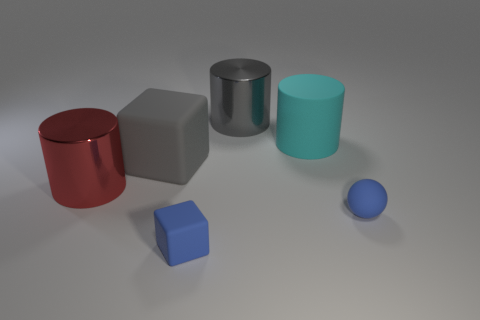There is a gray cylinder; is its size the same as the cylinder to the left of the large gray metal cylinder?
Make the answer very short. Yes. There is a rubber thing that is left of the tiny object left of the tiny ball; are there any tiny blue cubes on the left side of it?
Make the answer very short. No. What material is the big thing that is in front of the big gray block?
Your answer should be very brief. Metal. Do the ball and the cyan rubber cylinder have the same size?
Keep it short and to the point. No. What is the color of the cylinder that is on the left side of the cyan matte cylinder and on the right side of the small blue matte block?
Your answer should be compact. Gray. There is a large thing that is the same material as the gray cube; what is its shape?
Give a very brief answer. Cylinder. How many things are both on the left side of the tiny blue rubber cube and behind the red shiny cylinder?
Keep it short and to the point. 1. There is a red cylinder; are there any objects to the right of it?
Your answer should be very brief. Yes. There is a small matte object right of the small blue block; is its shape the same as the shiny object behind the gray rubber object?
Make the answer very short. No. What number of objects are either rubber balls or metallic cylinders that are in front of the cyan rubber object?
Offer a terse response. 2. 